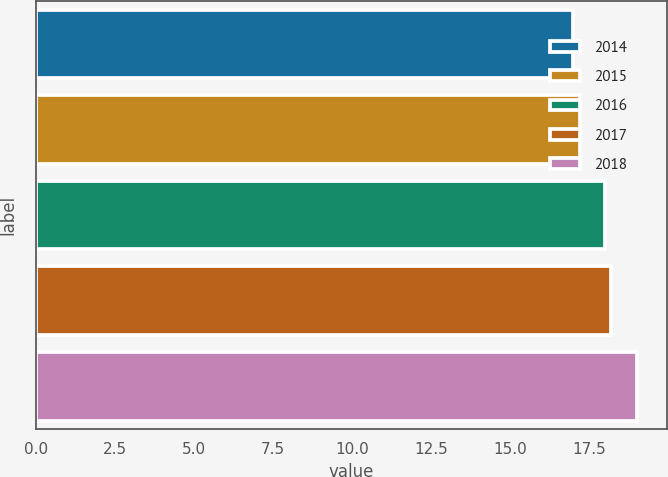Convert chart to OTSL. <chart><loc_0><loc_0><loc_500><loc_500><bar_chart><fcel>2014<fcel>2015<fcel>2016<fcel>2017<fcel>2018<nl><fcel>17<fcel>17.2<fcel>18<fcel>18.2<fcel>19<nl></chart> 